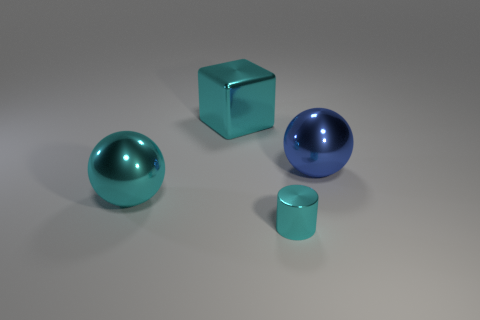Add 4 small cyan shiny objects. How many objects exist? 8 Subtract all blocks. How many objects are left? 3 Subtract 1 balls. How many balls are left? 1 Add 1 big blocks. How many big blocks are left? 2 Add 2 gray matte spheres. How many gray matte spheres exist? 2 Subtract all blue balls. How many balls are left? 1 Subtract 0 brown spheres. How many objects are left? 4 Subtract all red blocks. Subtract all blue balls. How many blocks are left? 1 Subtract all big blue metal things. Subtract all cyan metal spheres. How many objects are left? 2 